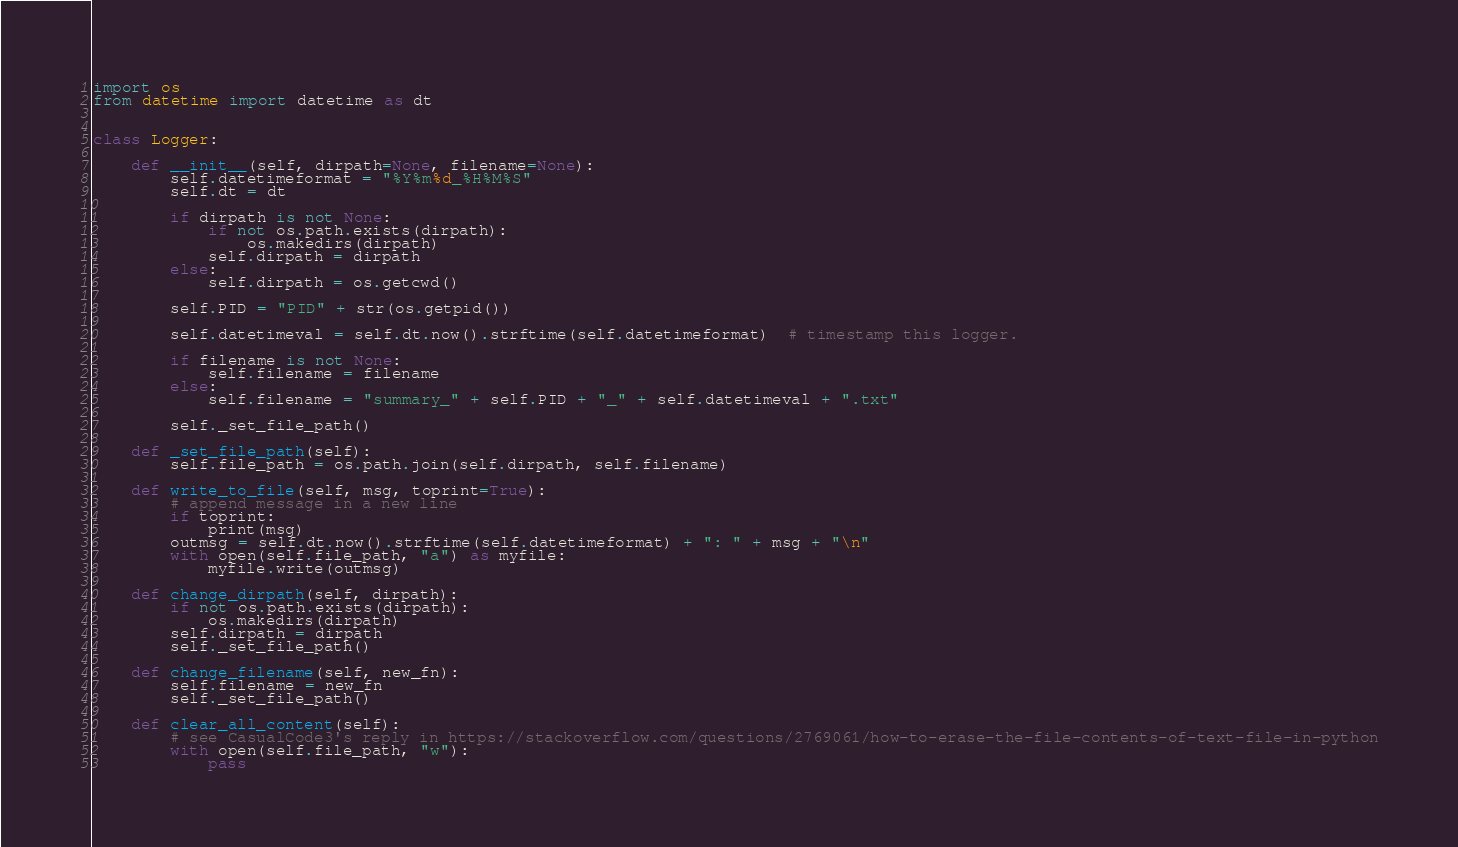Convert code to text. <code><loc_0><loc_0><loc_500><loc_500><_Python_>import os
from datetime import datetime as dt


class Logger:

    def __init__(self, dirpath=None, filename=None):
        self.datetimeformat = "%Y%m%d_%H%M%S"
        self.dt = dt

        if dirpath is not None:
            if not os.path.exists(dirpath):
                os.makedirs(dirpath)
            self.dirpath = dirpath
        else:
            self.dirpath = os.getcwd()

        self.PID = "PID" + str(os.getpid())

        self.datetimeval = self.dt.now().strftime(self.datetimeformat)  # timestamp this logger.

        if filename is not None:
            self.filename = filename
        else:
            self.filename = "summary_" + self.PID + "_" + self.datetimeval + ".txt"

        self._set_file_path()

    def _set_file_path(self):
        self.file_path = os.path.join(self.dirpath, self.filename)

    def write_to_file(self, msg, toprint=True):
        # append message in a new line
        if toprint:
            print(msg)
        outmsg = self.dt.now().strftime(self.datetimeformat) + ": " + msg + "\n"
        with open(self.file_path, "a") as myfile:
            myfile.write(outmsg)

    def change_dirpath(self, dirpath):
        if not os.path.exists(dirpath):
            os.makedirs(dirpath)
        self.dirpath = dirpath
        self._set_file_path()

    def change_filename(self, new_fn):
        self.filename = new_fn
        self._set_file_path()

    def clear_all_content(self):
        # see CasualCode3's reply in https://stackoverflow.com/questions/2769061/how-to-erase-the-file-contents-of-text-file-in-python
        with open(self.file_path, "w"):
            pass
</code> 